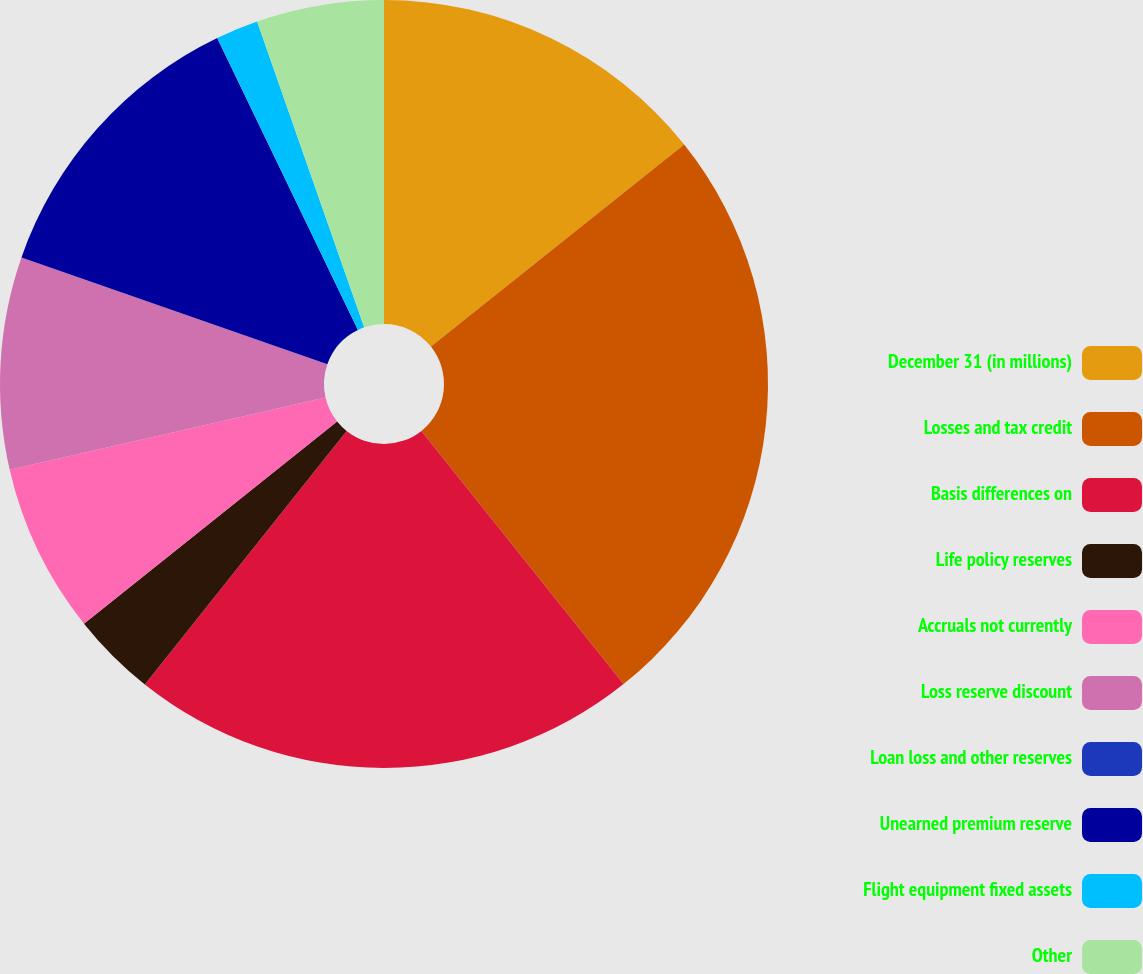Convert chart. <chart><loc_0><loc_0><loc_500><loc_500><pie_chart><fcel>December 31 (in millions)<fcel>Losses and tax credit<fcel>Basis differences on<fcel>Life policy reserves<fcel>Accruals not currently<fcel>Loss reserve discount<fcel>Loan loss and other reserves<fcel>Unearned premium reserve<fcel>Flight equipment fixed assets<fcel>Other<nl><fcel>14.28%<fcel>24.99%<fcel>21.42%<fcel>3.57%<fcel>7.14%<fcel>8.93%<fcel>0.0%<fcel>12.5%<fcel>1.79%<fcel>5.36%<nl></chart> 